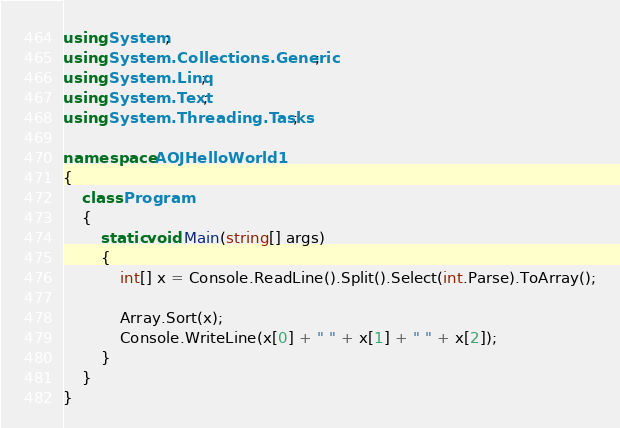Convert code to text. <code><loc_0><loc_0><loc_500><loc_500><_C#_>using System;
using System.Collections.Generic;
using System.Linq;
using System.Text;
using System.Threading.Tasks;

namespace AOJHelloWorld1
{
    class Program
    {
        static void Main(string[] args)
        {
            int[] x = Console.ReadLine().Split().Select(int.Parse).ToArray();
            
            Array.Sort(x);
            Console.WriteLine(x[0] + " " + x[1] + " " + x[2]);
        }
    }
}
</code> 